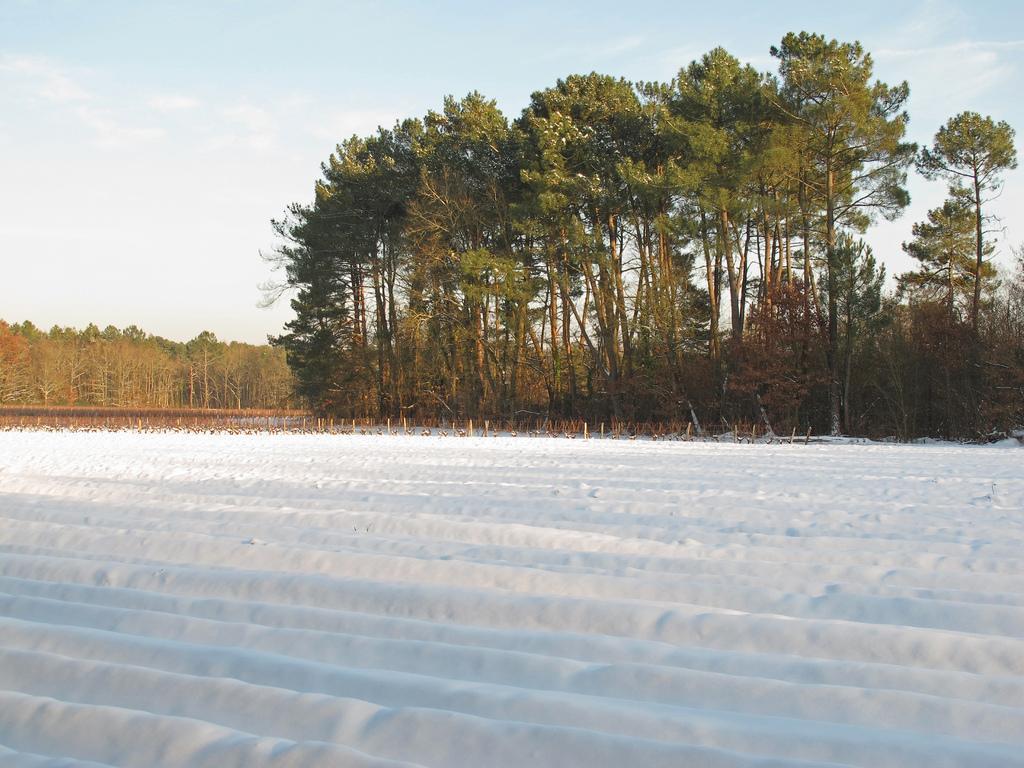Can you describe this image briefly? This is snow. In the background we can see trees and sky. 